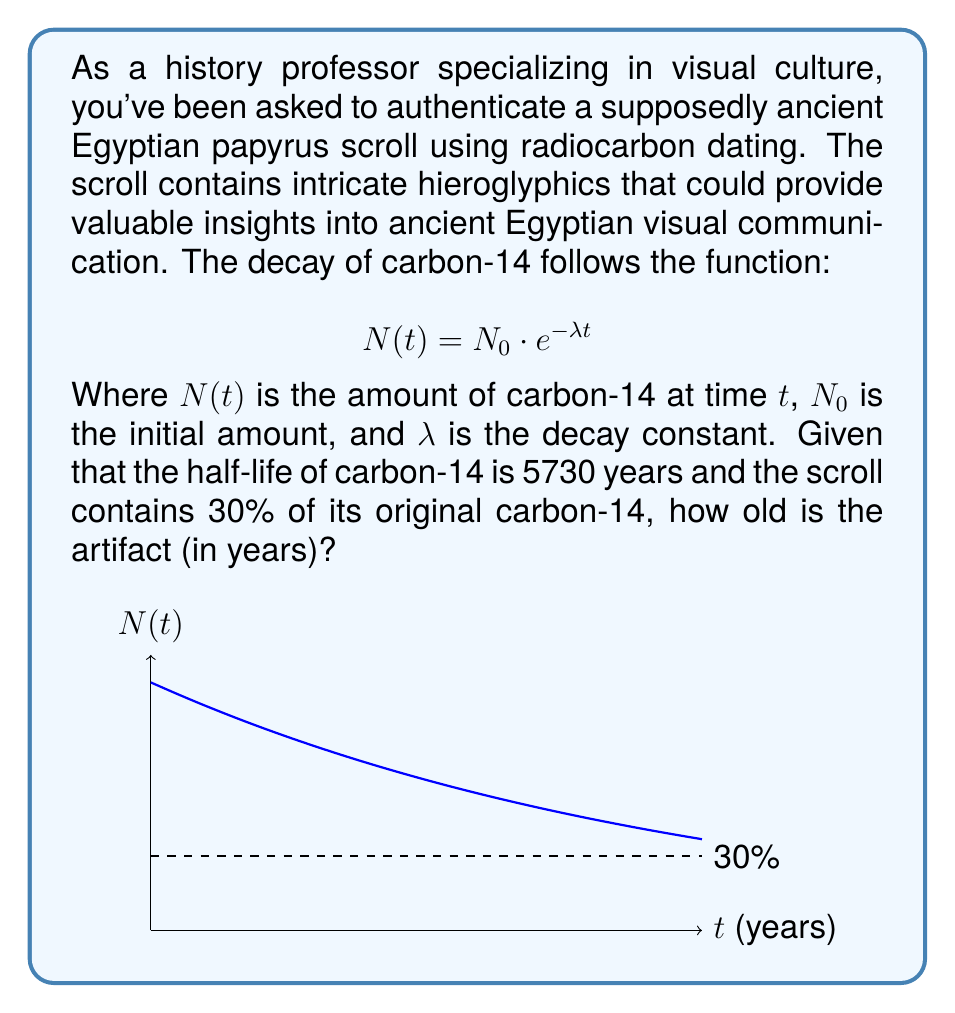What is the answer to this math problem? Let's approach this step-by-step:

1) We're given the decay function: $N(t) = N_0 \cdot e^{-\lambda t}$

2) We know that the scroll contains 30% of its original carbon-14. This means:
   $\frac{N(t)}{N_0} = 0.30$

3) Substituting this into our equation:
   $0.30 = e^{-\lambda t}$

4) We need to find $\lambda$. We can do this using the half-life formula:
   $\lambda = \frac{\ln(2)}{t_{1/2}} = \frac{\ln(2)}{5730} \approx 0.000121$

5) Now we can solve for $t$:
   $\ln(0.30) = -\lambda t$
   $t = -\frac{\ln(0.30)}{\lambda}$

6) Substituting in our value for $\lambda$:
   $t = -\frac{\ln(0.30)}{0.000121} \approx 9968.5$

Therefore, the scroll is approximately 9969 years old.
Answer: 9969 years 